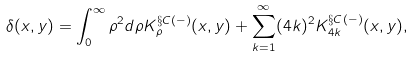Convert formula to latex. <formula><loc_0><loc_0><loc_500><loc_500>\delta ( x , y ) = \int ^ { \infty } _ { 0 } \rho ^ { 2 } d \rho K ^ { \S C ( - ) } _ { \rho } ( x , y ) + \sum ^ { \infty } _ { k = 1 } ( 4 k ) ^ { 2 } K ^ { \S C ( - ) } _ { 4 k } ( x , y ) ,</formula> 